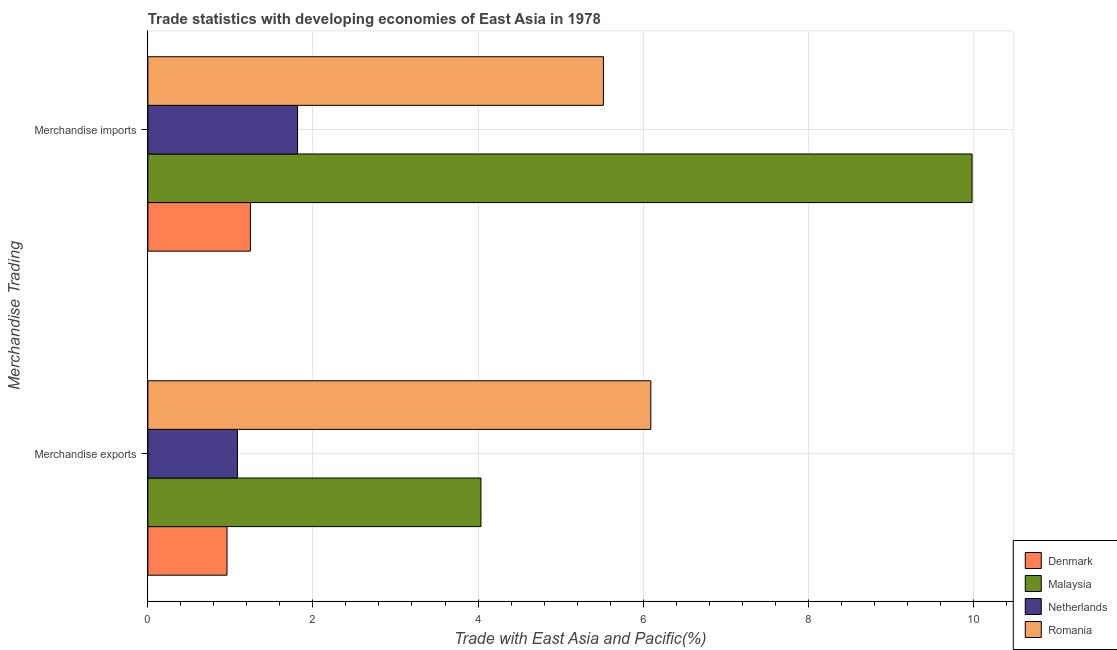How many different coloured bars are there?
Offer a terse response. 4. How many groups of bars are there?
Provide a short and direct response. 2. Are the number of bars per tick equal to the number of legend labels?
Offer a terse response. Yes. What is the label of the 2nd group of bars from the top?
Your answer should be compact. Merchandise exports. What is the merchandise imports in Romania?
Offer a terse response. 5.52. Across all countries, what is the maximum merchandise exports?
Offer a very short reply. 6.09. Across all countries, what is the minimum merchandise exports?
Your answer should be very brief. 0.96. In which country was the merchandise imports maximum?
Keep it short and to the point. Malaysia. What is the total merchandise imports in the graph?
Ensure brevity in your answer.  18.56. What is the difference between the merchandise imports in Netherlands and that in Denmark?
Give a very brief answer. 0.57. What is the difference between the merchandise exports in Netherlands and the merchandise imports in Malaysia?
Provide a succinct answer. -8.9. What is the average merchandise exports per country?
Give a very brief answer. 3.04. What is the difference between the merchandise imports and merchandise exports in Netherlands?
Ensure brevity in your answer.  0.73. What is the ratio of the merchandise imports in Denmark to that in Malaysia?
Give a very brief answer. 0.12. Is the merchandise exports in Romania less than that in Denmark?
Offer a terse response. No. What does the 4th bar from the top in Merchandise imports represents?
Give a very brief answer. Denmark. Are all the bars in the graph horizontal?
Your answer should be very brief. Yes. What is the difference between two consecutive major ticks on the X-axis?
Make the answer very short. 2. Does the graph contain any zero values?
Your answer should be very brief. No. Where does the legend appear in the graph?
Your answer should be compact. Bottom right. How are the legend labels stacked?
Your answer should be compact. Vertical. What is the title of the graph?
Your answer should be compact. Trade statistics with developing economies of East Asia in 1978. Does "Kenya" appear as one of the legend labels in the graph?
Keep it short and to the point. No. What is the label or title of the X-axis?
Your response must be concise. Trade with East Asia and Pacific(%). What is the label or title of the Y-axis?
Your response must be concise. Merchandise Trading. What is the Trade with East Asia and Pacific(%) in Denmark in Merchandise exports?
Provide a succinct answer. 0.96. What is the Trade with East Asia and Pacific(%) in Malaysia in Merchandise exports?
Provide a succinct answer. 4.04. What is the Trade with East Asia and Pacific(%) of Netherlands in Merchandise exports?
Ensure brevity in your answer.  1.09. What is the Trade with East Asia and Pacific(%) of Romania in Merchandise exports?
Offer a terse response. 6.09. What is the Trade with East Asia and Pacific(%) in Denmark in Merchandise imports?
Make the answer very short. 1.24. What is the Trade with East Asia and Pacific(%) of Malaysia in Merchandise imports?
Ensure brevity in your answer.  9.99. What is the Trade with East Asia and Pacific(%) of Netherlands in Merchandise imports?
Offer a very short reply. 1.81. What is the Trade with East Asia and Pacific(%) of Romania in Merchandise imports?
Make the answer very short. 5.52. Across all Merchandise Trading, what is the maximum Trade with East Asia and Pacific(%) in Denmark?
Offer a terse response. 1.24. Across all Merchandise Trading, what is the maximum Trade with East Asia and Pacific(%) of Malaysia?
Provide a short and direct response. 9.99. Across all Merchandise Trading, what is the maximum Trade with East Asia and Pacific(%) of Netherlands?
Your answer should be compact. 1.81. Across all Merchandise Trading, what is the maximum Trade with East Asia and Pacific(%) of Romania?
Your answer should be very brief. 6.09. Across all Merchandise Trading, what is the minimum Trade with East Asia and Pacific(%) in Denmark?
Provide a succinct answer. 0.96. Across all Merchandise Trading, what is the minimum Trade with East Asia and Pacific(%) in Malaysia?
Ensure brevity in your answer.  4.04. Across all Merchandise Trading, what is the minimum Trade with East Asia and Pacific(%) in Netherlands?
Offer a very short reply. 1.09. Across all Merchandise Trading, what is the minimum Trade with East Asia and Pacific(%) in Romania?
Your answer should be very brief. 5.52. What is the total Trade with East Asia and Pacific(%) of Denmark in the graph?
Give a very brief answer. 2.2. What is the total Trade with East Asia and Pacific(%) of Malaysia in the graph?
Your answer should be very brief. 14.02. What is the total Trade with East Asia and Pacific(%) of Netherlands in the graph?
Offer a terse response. 2.9. What is the total Trade with East Asia and Pacific(%) of Romania in the graph?
Your answer should be very brief. 11.61. What is the difference between the Trade with East Asia and Pacific(%) of Denmark in Merchandise exports and that in Merchandise imports?
Make the answer very short. -0.28. What is the difference between the Trade with East Asia and Pacific(%) in Malaysia in Merchandise exports and that in Merchandise imports?
Offer a terse response. -5.95. What is the difference between the Trade with East Asia and Pacific(%) of Netherlands in Merchandise exports and that in Merchandise imports?
Keep it short and to the point. -0.73. What is the difference between the Trade with East Asia and Pacific(%) of Romania in Merchandise exports and that in Merchandise imports?
Keep it short and to the point. 0.57. What is the difference between the Trade with East Asia and Pacific(%) in Denmark in Merchandise exports and the Trade with East Asia and Pacific(%) in Malaysia in Merchandise imports?
Offer a terse response. -9.03. What is the difference between the Trade with East Asia and Pacific(%) in Denmark in Merchandise exports and the Trade with East Asia and Pacific(%) in Netherlands in Merchandise imports?
Give a very brief answer. -0.85. What is the difference between the Trade with East Asia and Pacific(%) of Denmark in Merchandise exports and the Trade with East Asia and Pacific(%) of Romania in Merchandise imports?
Provide a succinct answer. -4.56. What is the difference between the Trade with East Asia and Pacific(%) of Malaysia in Merchandise exports and the Trade with East Asia and Pacific(%) of Netherlands in Merchandise imports?
Keep it short and to the point. 2.22. What is the difference between the Trade with East Asia and Pacific(%) of Malaysia in Merchandise exports and the Trade with East Asia and Pacific(%) of Romania in Merchandise imports?
Keep it short and to the point. -1.48. What is the difference between the Trade with East Asia and Pacific(%) of Netherlands in Merchandise exports and the Trade with East Asia and Pacific(%) of Romania in Merchandise imports?
Your response must be concise. -4.43. What is the average Trade with East Asia and Pacific(%) of Denmark per Merchandise Trading?
Give a very brief answer. 1.1. What is the average Trade with East Asia and Pacific(%) in Malaysia per Merchandise Trading?
Provide a succinct answer. 7.01. What is the average Trade with East Asia and Pacific(%) of Netherlands per Merchandise Trading?
Offer a terse response. 1.45. What is the average Trade with East Asia and Pacific(%) in Romania per Merchandise Trading?
Make the answer very short. 5.81. What is the difference between the Trade with East Asia and Pacific(%) of Denmark and Trade with East Asia and Pacific(%) of Malaysia in Merchandise exports?
Provide a short and direct response. -3.08. What is the difference between the Trade with East Asia and Pacific(%) of Denmark and Trade with East Asia and Pacific(%) of Netherlands in Merchandise exports?
Your answer should be compact. -0.13. What is the difference between the Trade with East Asia and Pacific(%) of Denmark and Trade with East Asia and Pacific(%) of Romania in Merchandise exports?
Your answer should be very brief. -5.13. What is the difference between the Trade with East Asia and Pacific(%) of Malaysia and Trade with East Asia and Pacific(%) of Netherlands in Merchandise exports?
Provide a short and direct response. 2.95. What is the difference between the Trade with East Asia and Pacific(%) of Malaysia and Trade with East Asia and Pacific(%) of Romania in Merchandise exports?
Provide a succinct answer. -2.06. What is the difference between the Trade with East Asia and Pacific(%) in Netherlands and Trade with East Asia and Pacific(%) in Romania in Merchandise exports?
Ensure brevity in your answer.  -5.01. What is the difference between the Trade with East Asia and Pacific(%) in Denmark and Trade with East Asia and Pacific(%) in Malaysia in Merchandise imports?
Provide a short and direct response. -8.74. What is the difference between the Trade with East Asia and Pacific(%) in Denmark and Trade with East Asia and Pacific(%) in Netherlands in Merchandise imports?
Make the answer very short. -0.57. What is the difference between the Trade with East Asia and Pacific(%) of Denmark and Trade with East Asia and Pacific(%) of Romania in Merchandise imports?
Ensure brevity in your answer.  -4.28. What is the difference between the Trade with East Asia and Pacific(%) in Malaysia and Trade with East Asia and Pacific(%) in Netherlands in Merchandise imports?
Ensure brevity in your answer.  8.17. What is the difference between the Trade with East Asia and Pacific(%) in Malaysia and Trade with East Asia and Pacific(%) in Romania in Merchandise imports?
Provide a short and direct response. 4.47. What is the difference between the Trade with East Asia and Pacific(%) of Netherlands and Trade with East Asia and Pacific(%) of Romania in Merchandise imports?
Provide a succinct answer. -3.71. What is the ratio of the Trade with East Asia and Pacific(%) of Denmark in Merchandise exports to that in Merchandise imports?
Your answer should be compact. 0.77. What is the ratio of the Trade with East Asia and Pacific(%) of Malaysia in Merchandise exports to that in Merchandise imports?
Your answer should be very brief. 0.4. What is the ratio of the Trade with East Asia and Pacific(%) in Netherlands in Merchandise exports to that in Merchandise imports?
Make the answer very short. 0.6. What is the ratio of the Trade with East Asia and Pacific(%) of Romania in Merchandise exports to that in Merchandise imports?
Keep it short and to the point. 1.1. What is the difference between the highest and the second highest Trade with East Asia and Pacific(%) in Denmark?
Provide a succinct answer. 0.28. What is the difference between the highest and the second highest Trade with East Asia and Pacific(%) in Malaysia?
Offer a very short reply. 5.95. What is the difference between the highest and the second highest Trade with East Asia and Pacific(%) in Netherlands?
Your answer should be compact. 0.73. What is the difference between the highest and the second highest Trade with East Asia and Pacific(%) of Romania?
Offer a very short reply. 0.57. What is the difference between the highest and the lowest Trade with East Asia and Pacific(%) in Denmark?
Give a very brief answer. 0.28. What is the difference between the highest and the lowest Trade with East Asia and Pacific(%) in Malaysia?
Provide a succinct answer. 5.95. What is the difference between the highest and the lowest Trade with East Asia and Pacific(%) in Netherlands?
Keep it short and to the point. 0.73. What is the difference between the highest and the lowest Trade with East Asia and Pacific(%) of Romania?
Provide a succinct answer. 0.57. 